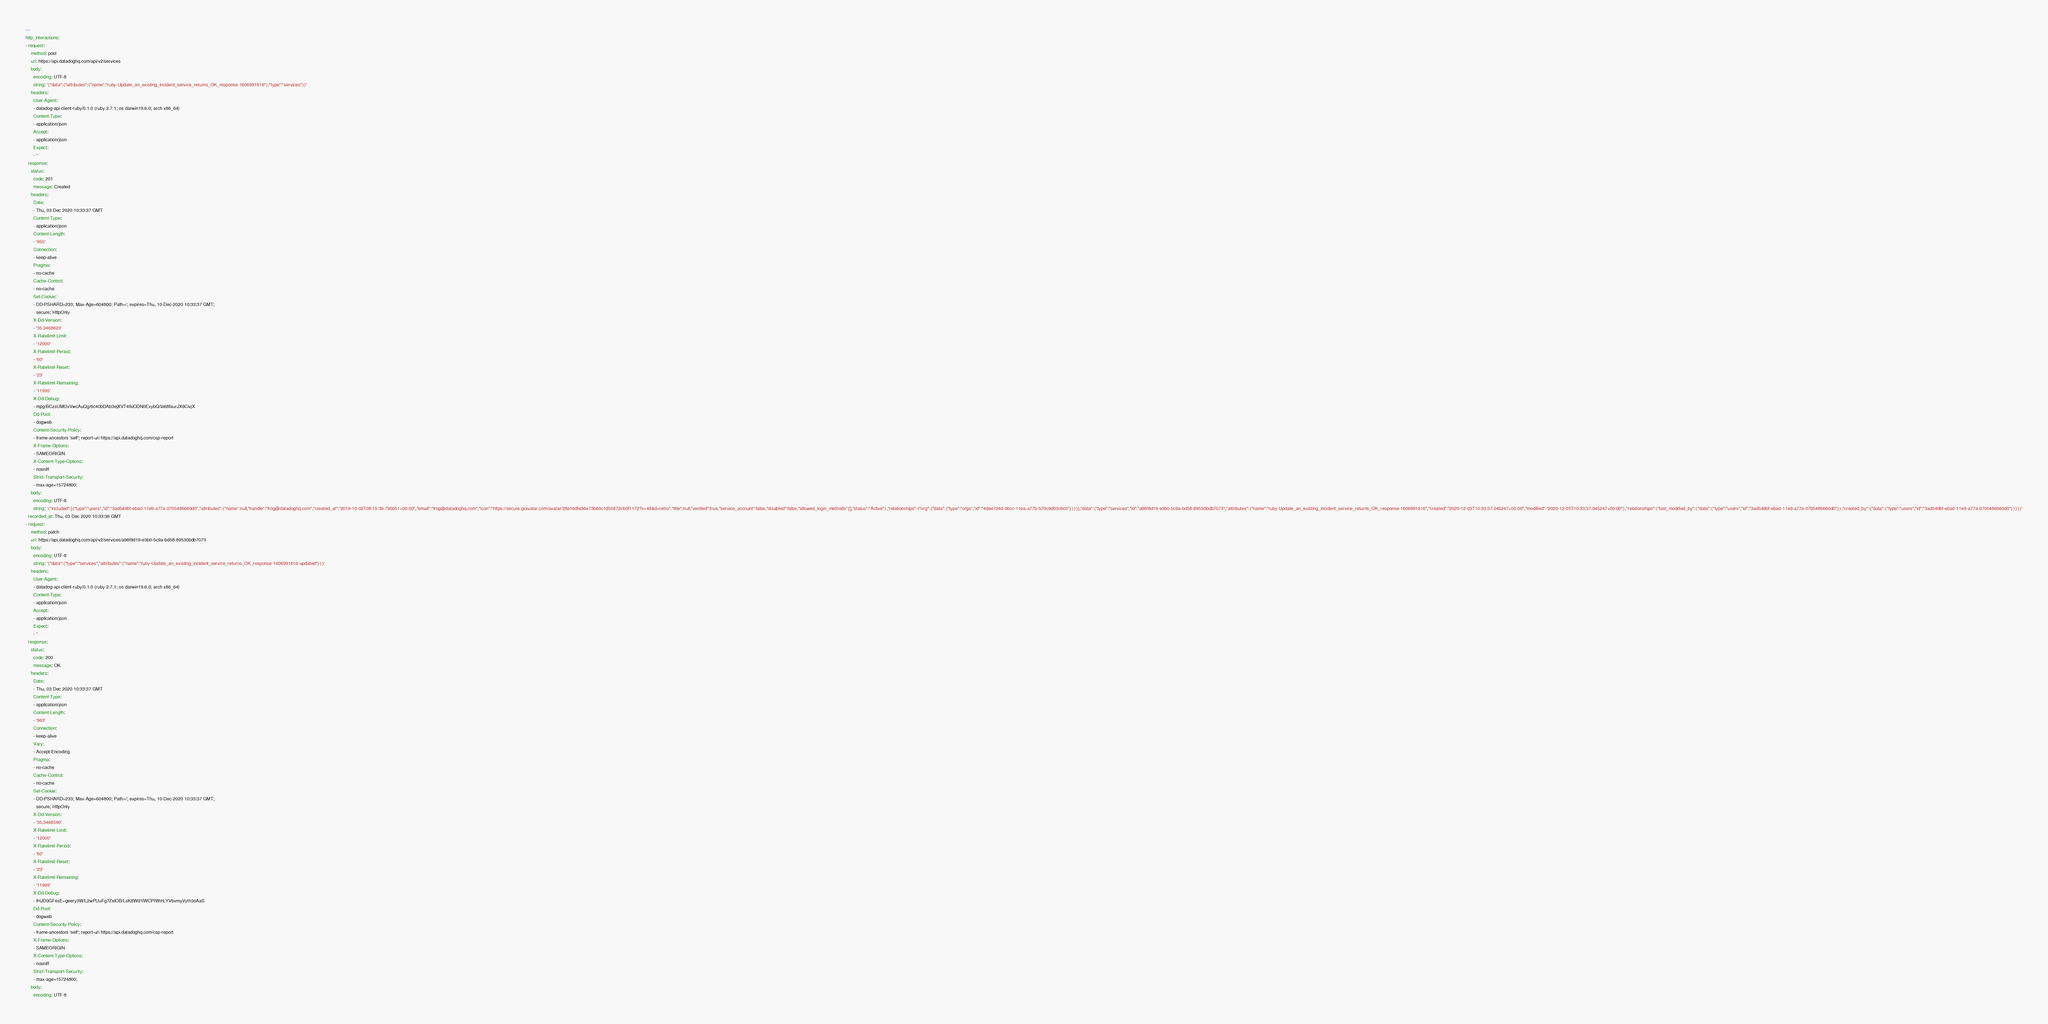<code> <loc_0><loc_0><loc_500><loc_500><_YAML_>---
http_interactions:
- request:
    method: post
    uri: https://api.datadoghq.com/api/v2/services
    body:
      encoding: UTF-8
      string: '{"data":{"attributes":{"name":"ruby-Update_an_existing_incident_service_returns_OK_response-1606991616"},"type":"services"}}'
    headers:
      User-Agent:
      - datadog-api-client-ruby/0.1.0 (ruby 2.7.1; os darwin19.6.0; arch x86_64)
      Content-Type:
      - application/json
      Accept:
      - application/json
      Expect:
      - ''
  response:
    status:
      code: 201
      message: Created
    headers:
      Date:
      - Thu, 03 Dec 2020 10:33:37 GMT
      Content-Type:
      - application/json
      Content-Length:
      - '955'
      Connection:
      - keep-alive
      Pragma:
      - no-cache
      Cache-Control:
      - no-cache
      Set-Cookie:
      - DD-PSHARD=233; Max-Age=604800; Path=/; expires=Thu, 10-Dec-2020 10:33:37 GMT;
        secure; HttpOnly
      X-Dd-Version:
      - '35.3468623'
      X-Ratelimit-Limit:
      - '12000'
      X-Ratelimit-Period:
      - '60'
      X-Ratelimit-Reset:
      - '23'
      X-Ratelimit-Remaining:
      - '11995'
      X-Dd-Debug:
      - mpg/BCzsUMOxVwcAuQg/6c40bDAb3ejXVT4tkiODN0ExybQ/Ia68faurJX6CivjX
      Dd-Pool:
      - dogweb
      Content-Security-Policy:
      - frame-ancestors 'self'; report-uri https://api.datadoghq.com/csp-report
      X-Frame-Options:
      - SAMEORIGIN
      X-Content-Type-Options:
      - nosniff
      Strict-Transport-Security:
      - max-age=15724800;
    body:
      encoding: UTF-8
      string: '{"included":[{"type":"users","id":"3ad549bf-eba0-11e9-a77a-0705486660d0","attributes":{"name":null,"handle":"frog@datadoghq.com","created_at":"2019-10-02T08:15:39.795051+00:00","email":"frog@datadoghq.com","icon":"https://secure.gravatar.com/avatar/28a16dfe36e73b60c1d55872cb0f1172?s=48&d=retro","title":null,"verified":true,"service_account":false,"disabled":false,"allowed_login_methods":[],"status":"Active"},"relationships":{"org":{"data":{"type":"orgs","id":"4dee724d-00cc-11ea-a77b-570c9d03c6c5"}}}}],"data":{"type":"services","id":"a96f8d19-e3b0-5c9a-bd58-89530bdb7073","attributes":{"name":"ruby-Update_an_existing_incident_service_returns_OK_response-1606991616","created":"2020-12-03T10:33:37.045247+00:00","modified":"2020-12-03T10:33:37.045247+00:00"},"relationships":{"last_modified_by":{"data":{"type":"users","id":"3ad549bf-eba0-11e9-a77a-0705486660d0"}},"created_by":{"data":{"type":"users","id":"3ad549bf-eba0-11e9-a77a-0705486660d0"}}}}}'
  recorded_at: Thu, 03 Dec 2020 10:33:36 GMT
- request:
    method: patch
    uri: https://api.datadoghq.com/api/v2/services/a96f8d19-e3b0-5c9a-bd58-89530bdb7073
    body:
      encoding: UTF-8
      string: '{"data":{"type":"services","attributes":{"name":"ruby-Update_an_existing_incident_service_returns_OK_response-1606991616-updated"}}}'
    headers:
      User-Agent:
      - datadog-api-client-ruby/0.1.0 (ruby 2.7.1; os darwin19.6.0; arch x86_64)
      Content-Type:
      - application/json
      Accept:
      - application/json
      Expect:
      - ''
  response:
    status:
      code: 200
      message: OK
    headers:
      Date:
      - Thu, 03 Dec 2020 10:33:37 GMT
      Content-Type:
      - application/json
      Content-Length:
      - '963'
      Connection:
      - keep-alive
      Vary:
      - Accept-Encoding
      Pragma:
      - no-cache
      Cache-Control:
      - no-cache
      Set-Cookie:
      - DD-PSHARD=233; Max-Age=604800; Path=/; expires=Thu, 10-Dec-2020 10:33:37 GMT;
        secure; HttpOnly
      X-Dd-Version:
      - '35.3468590'
      X-Ratelimit-Limit:
      - '12000'
      X-Ratelimit-Period:
      - '60'
      X-Ratelimit-Reset:
      - '23'
      X-Ratelimit-Remaining:
      - '11999'
      X-Dd-Debug:
      - fHJD0GFesE+geery3W/L2wPUuFg7ZelOB/LsK8Wd1lWCPIWmLYVbvmyVyth3oAaS
      Dd-Pool:
      - dogweb
      Content-Security-Policy:
      - frame-ancestors 'self'; report-uri https://api.datadoghq.com/csp-report
      X-Frame-Options:
      - SAMEORIGIN
      X-Content-Type-Options:
      - nosniff
      Strict-Transport-Security:
      - max-age=15724800;
    body:
      encoding: UTF-8</code> 